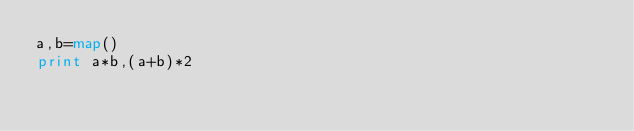Convert code to text. <code><loc_0><loc_0><loc_500><loc_500><_Python_>a,b=map()
print a*b,(a+b)*2
</code> 